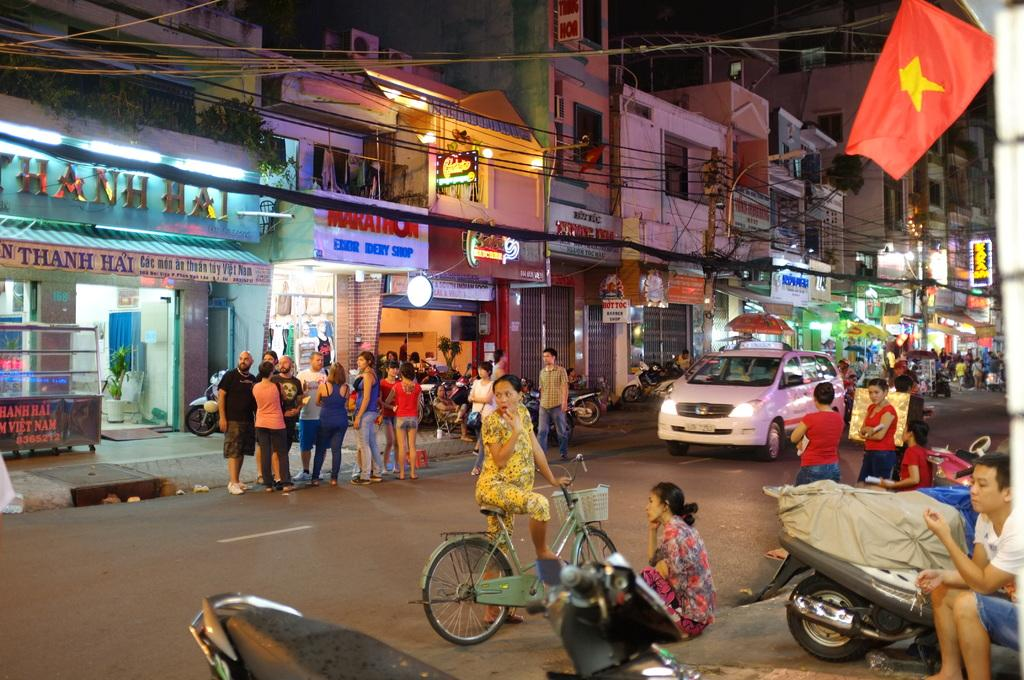<image>
Create a compact narrative representing the image presented. A group of people are gathered on the street in front of several stores, including Marathon Embr Idery Shop in Vietnam. 